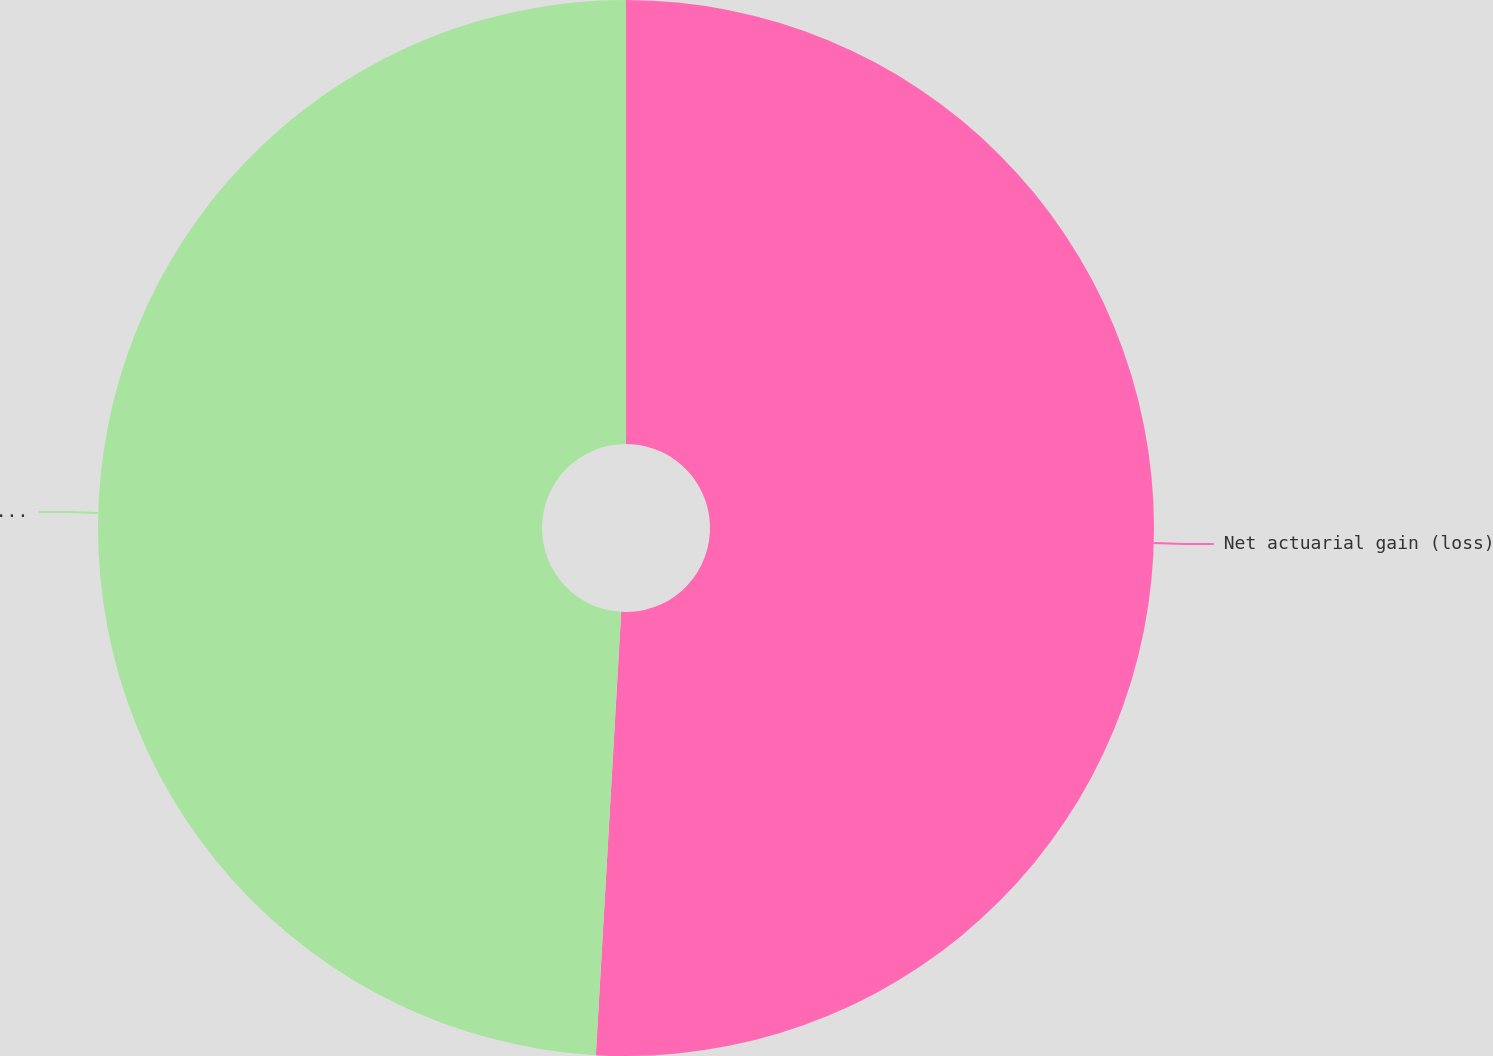<chart> <loc_0><loc_0><loc_500><loc_500><pie_chart><fcel>Net actuarial gain (loss)<fcel>Total recognized in Other<nl><fcel>50.91%<fcel>49.09%<nl></chart> 